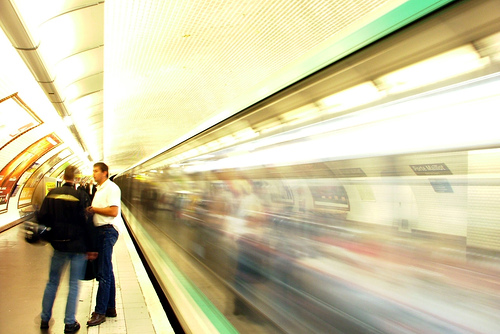What artistic effect is displayed in this image of the subway? The image showcases a motion blur effect, achieved by using a slow shutter speed on the camera. This effect emphasizes the movement of the train, giving a sense of speed and dynamism to the scene, while the stationary characters are in sharp contrast, which creates a compelling visual narrative about the pace of urban life. 